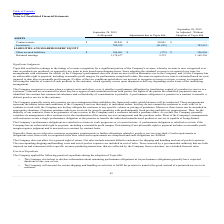According to Plexus's financial document, What was the adjustments due to Topic 606 for Contract Assets? According to the financial document, 90,841 (in thousands). The relevant text states: "Contract assets $ 90,841 $ 90,841 $ —..." Also, What was the balance before the adjustment due to Topic 606 for Retained earnings? According to the financial document, 1,178,677 (in thousands). The relevant text states: "Retained earnings 1,178,677 9,321 1,169,356..." Also, What was the balance after the adjustment due to Topic 606 for Inventories? According to the financial document, 782,833 (in thousands). The relevant text states: "Inventories 700,938 (81,895) 782,833..." Also, How many types of assets and liabilities had adjustments that exceeded $10,000 thousand? Counting the relevant items in the document: Contract assets, Inventories, I find 2 instances. The key data points involved are: Contract assets, Inventories. Also, can you calculate: What was the difference between the balance before adjustment for Retained earnings and Other accrued liabilities? Based on the calculation: 1,178,677-106,461, the result is 1072216 (in thousands). This is based on the information: "Retained earnings 1,178,677 9,321 1,169,356 SHAREHOLDERS' EQUITY Other accrued liabilities $ 106,461 $ (375) $ 106,836..." The key data points involved are: 1,178,677, 106,461. Also, can you calculate: What was the percentage change in other accrued liabilities due to adjustment from Topic 606? To answer this question, I need to perform calculations using the financial data. The calculation is: (106,836-106,461)/106,461, which equals 0.35 (percentage). This is based on the information: "ITY Other accrued liabilities $ 106,461 $ (375) $ 106,836 SHAREHOLDERS' EQUITY Other accrued liabilities $ 106,461 $ (375) $ 106,836..." The key data points involved are: 106,461, 106,836. 